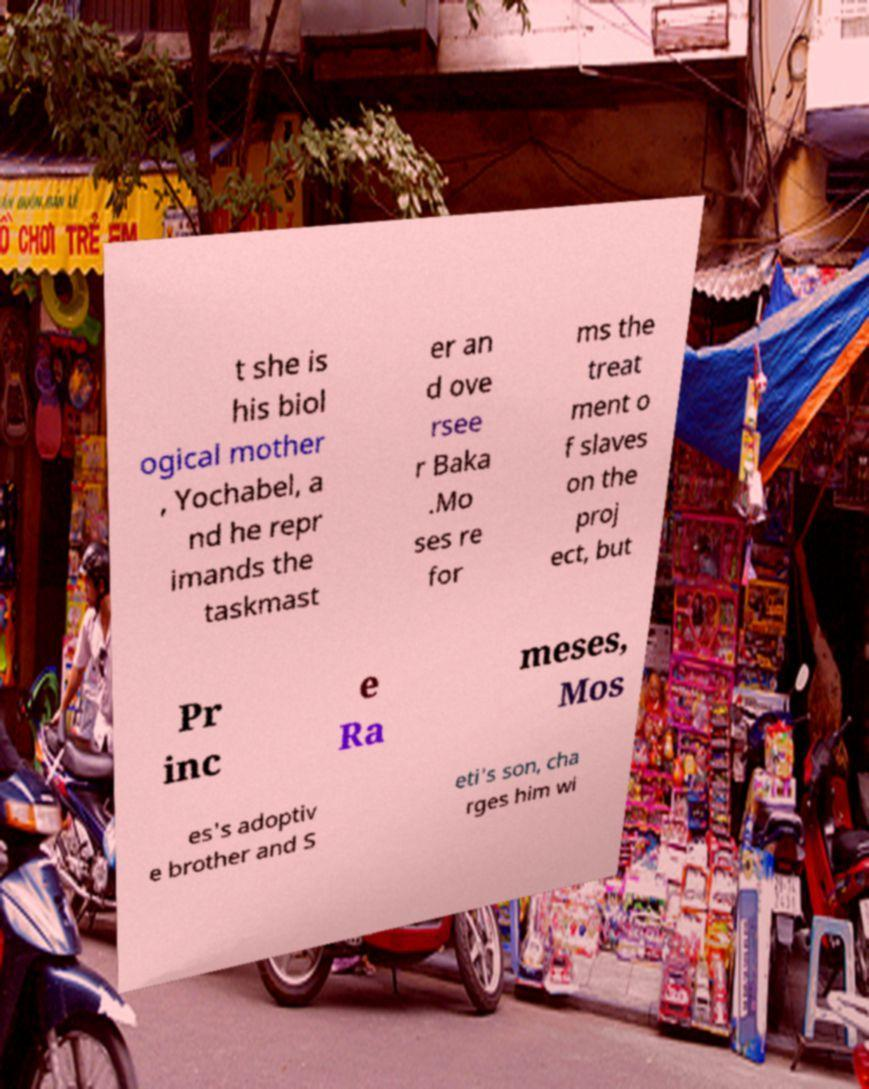Can you read and provide the text displayed in the image?This photo seems to have some interesting text. Can you extract and type it out for me? t she is his biol ogical mother , Yochabel, a nd he repr imands the taskmast er an d ove rsee r Baka .Mo ses re for ms the treat ment o f slaves on the proj ect, but Pr inc e Ra meses, Mos es's adoptiv e brother and S eti's son, cha rges him wi 